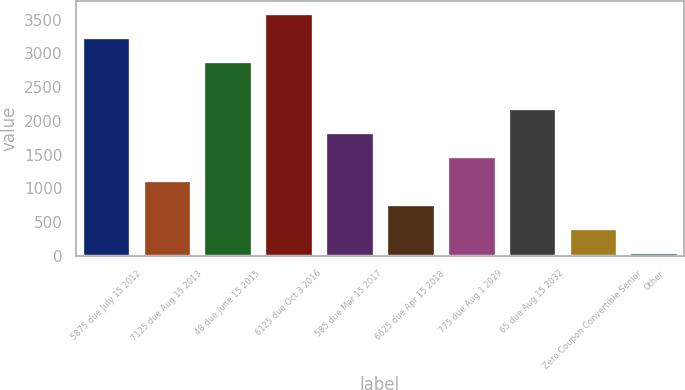<chart> <loc_0><loc_0><loc_500><loc_500><bar_chart><fcel>5875 due July 15 2012<fcel>7125 due Aug 15 2013<fcel>48 due June 15 2015<fcel>6125 due Oct 3 2016<fcel>585 due Mar 15 2017<fcel>6625 due Apr 15 2018<fcel>775 due Aug 1 2029<fcel>65 due Aug 15 2032<fcel>Zero Coupon Convertible Senior<fcel>Other<nl><fcel>3248.9<fcel>1118.3<fcel>2893.8<fcel>3604<fcel>1828.5<fcel>763.2<fcel>1473.4<fcel>2183.6<fcel>408.1<fcel>53<nl></chart> 